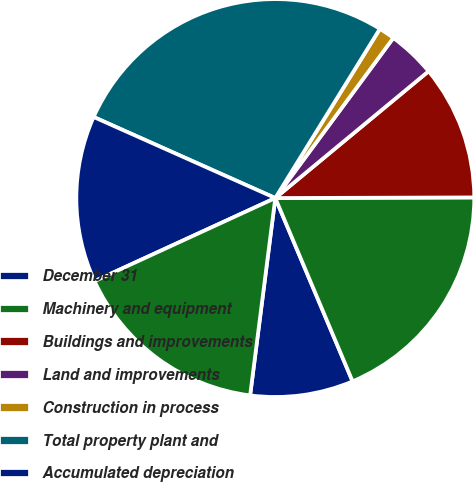Convert chart to OTSL. <chart><loc_0><loc_0><loc_500><loc_500><pie_chart><fcel>December 31<fcel>Machinery and equipment<fcel>Buildings and improvements<fcel>Land and improvements<fcel>Construction in process<fcel>Total property plant and<fcel>Accumulated depreciation<fcel>Property plant and equipment<nl><fcel>8.37%<fcel>18.7%<fcel>10.95%<fcel>3.89%<fcel>1.3%<fcel>27.13%<fcel>13.54%<fcel>16.12%<nl></chart> 